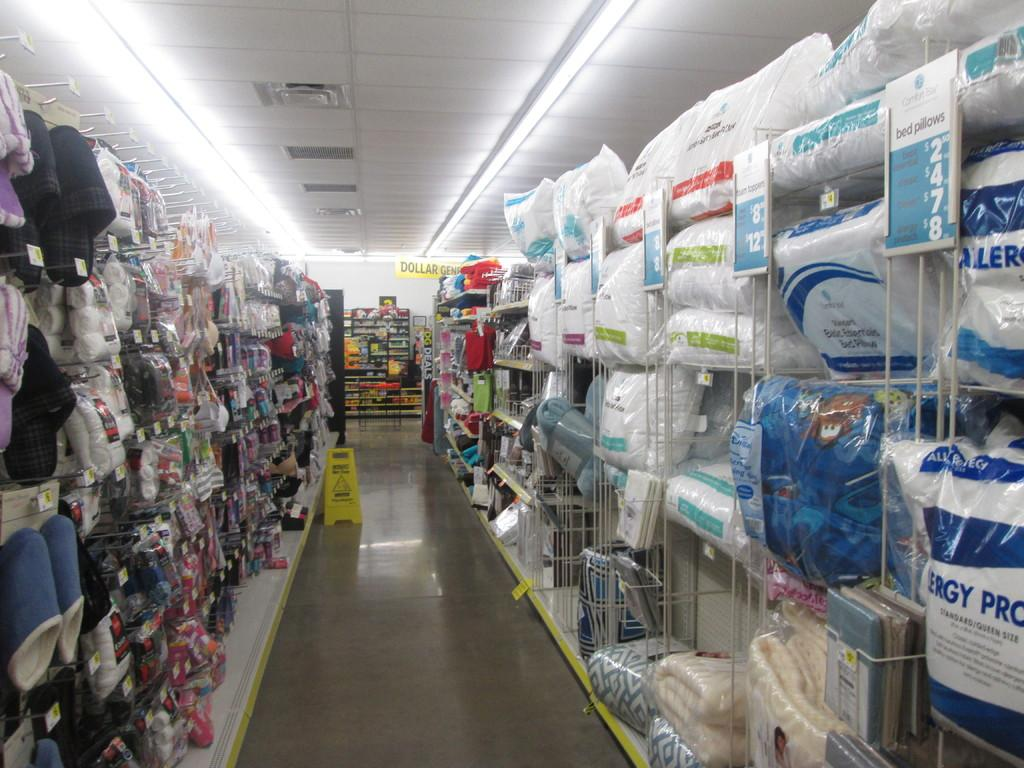<image>
Share a concise interpretation of the image provided. shelves of a store with things like Basic Essentials Bed Pillows 